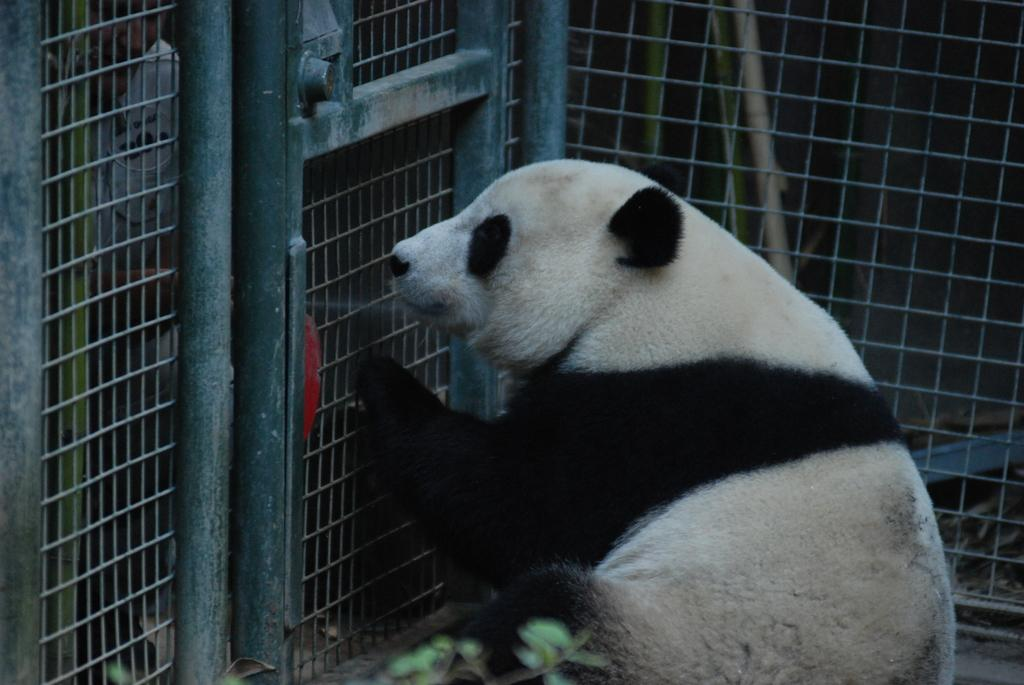What type of animal is in the picture? There is a panda in the picture. Where is the panda located in relation to the cage? The panda is near a cage. What other object can be seen in the picture? There is a small plant in the picture. What type of tent is set up near the panda in the image? There is no tent present in the image; it only features a panda, a cage, and a small plant. 